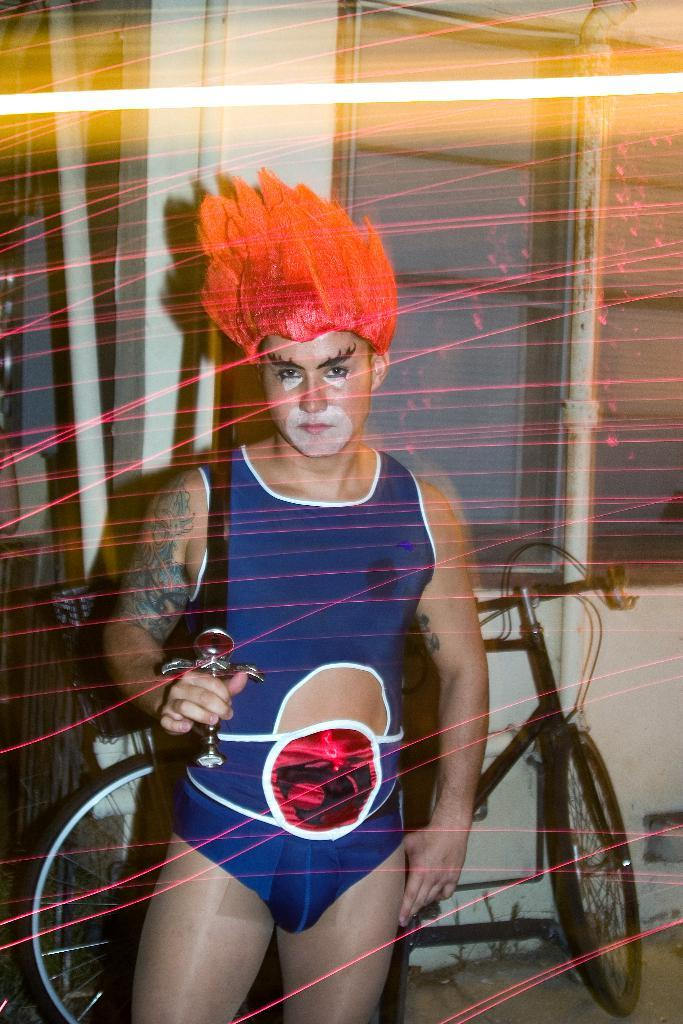Who or what is present in the image? There is a person in the image. What can be seen in the background of the image? There is a bicycle and a wall in the background of the image. How many ants are crawling on the person in the image? There are no ants visible in the image. What type of pest is present in the image? There are no pests present in the image. 